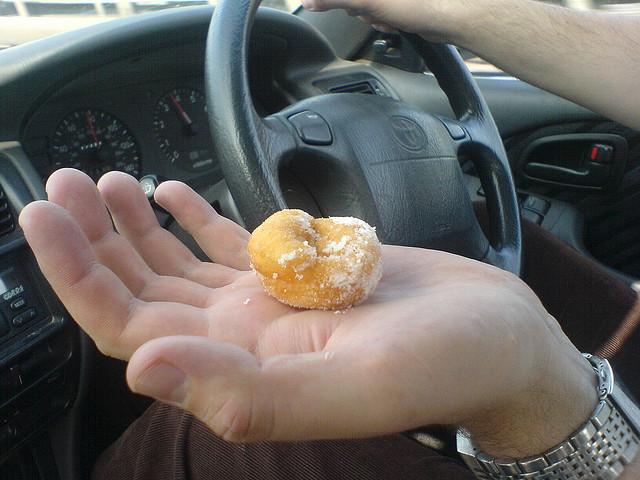What does this man have on his wrist?
Give a very brief answer. Watch. Was this edible item made with oil?
Write a very short answer. Yes. What is this cars make?
Be succinct. Toyota. 